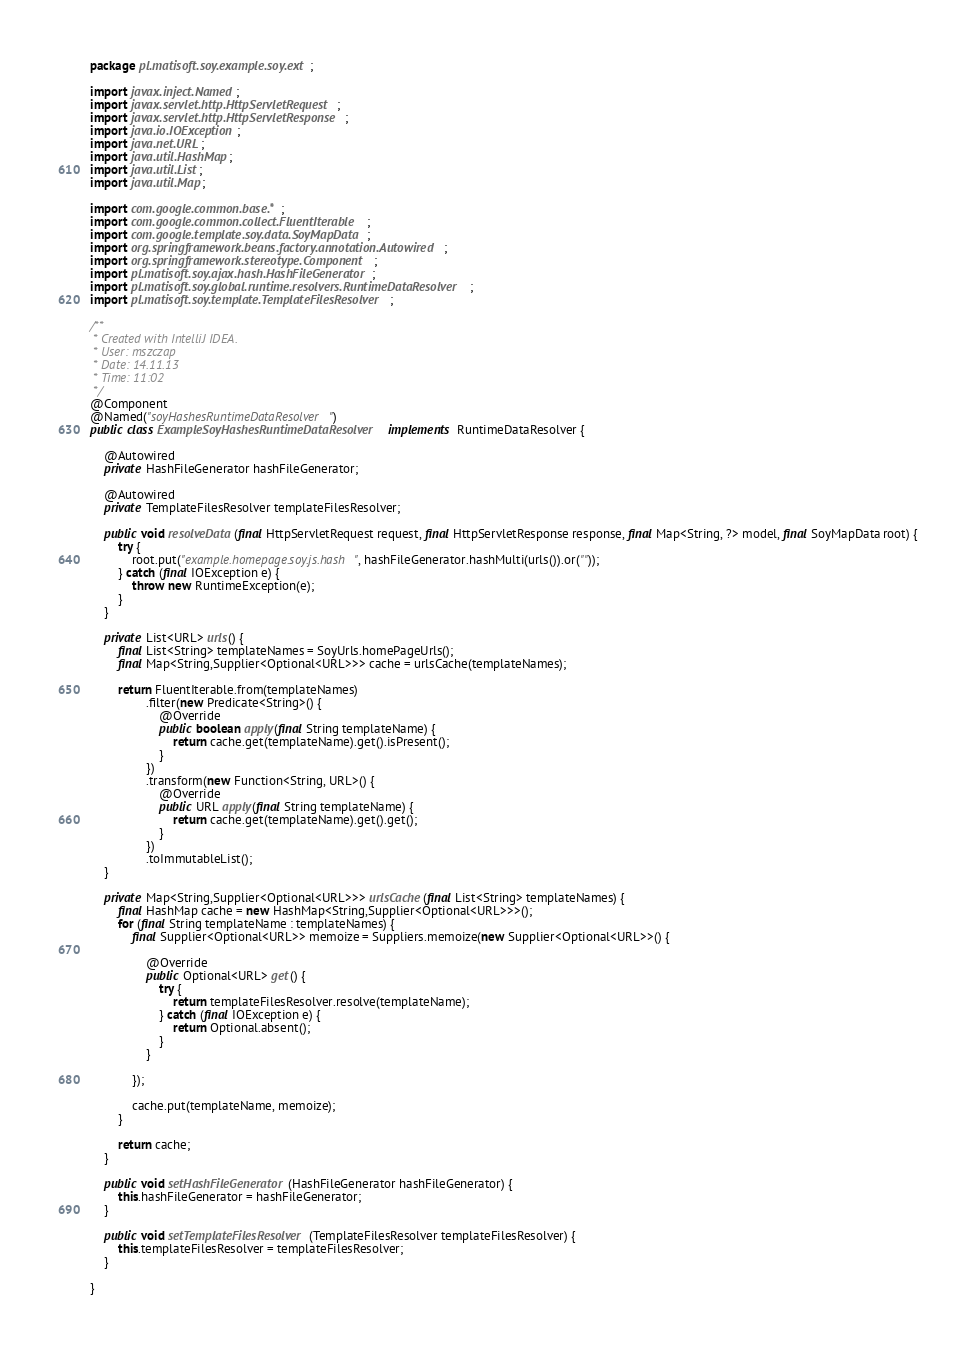<code> <loc_0><loc_0><loc_500><loc_500><_Java_>package pl.matisoft.soy.example.soy.ext;

import javax.inject.Named;
import javax.servlet.http.HttpServletRequest;
import javax.servlet.http.HttpServletResponse;
import java.io.IOException;
import java.net.URL;
import java.util.HashMap;
import java.util.List;
import java.util.Map;

import com.google.common.base.*;
import com.google.common.collect.FluentIterable;
import com.google.template.soy.data.SoyMapData;
import org.springframework.beans.factory.annotation.Autowired;
import org.springframework.stereotype.Component;
import pl.matisoft.soy.ajax.hash.HashFileGenerator;
import pl.matisoft.soy.global.runtime.resolvers.RuntimeDataResolver;
import pl.matisoft.soy.template.TemplateFilesResolver;

/**
 * Created with IntelliJ IDEA.
 * User: mszczap
 * Date: 14.11.13
 * Time: 11:02
 */
@Component
@Named("soyHashesRuntimeDataResolver")
public class ExampleSoyHashesRuntimeDataResolver implements RuntimeDataResolver {

    @Autowired
    private HashFileGenerator hashFileGenerator;

    @Autowired
    private TemplateFilesResolver templateFilesResolver;

    public void resolveData(final HttpServletRequest request, final HttpServletResponse response, final Map<String, ?> model, final SoyMapData root) {
        try {
            root.put("example.homepage.soy.js.hash", hashFileGenerator.hashMulti(urls()).or(""));
        } catch (final IOException e) {
            throw new RuntimeException(e);
        }
    }

    private List<URL> urls() {
        final List<String> templateNames = SoyUrls.homePageUrls();
        final Map<String,Supplier<Optional<URL>>> cache = urlsCache(templateNames);

        return FluentIterable.from(templateNames)
                .filter(new Predicate<String>() {
                    @Override
                    public boolean apply(final String templateName) {
                        return cache.get(templateName).get().isPresent();
                    }
                })
                .transform(new Function<String, URL>() {
                    @Override
                    public URL apply(final String templateName) {
                        return cache.get(templateName).get().get();
                    }
                })
                .toImmutableList();
    }

    private Map<String,Supplier<Optional<URL>>> urlsCache(final List<String> templateNames) {
        final HashMap cache = new HashMap<String,Supplier<Optional<URL>>>();
        for (final String templateName : templateNames) {
            final Supplier<Optional<URL>> memoize = Suppliers.memoize(new Supplier<Optional<URL>>() {

                @Override
                public Optional<URL> get() {
                    try {
                        return templateFilesResolver.resolve(templateName);
                    } catch (final IOException e) {
                        return Optional.absent();
                    }
                }

            });

            cache.put(templateName, memoize);
        }

        return cache;
    }

    public void setHashFileGenerator(HashFileGenerator hashFileGenerator) {
        this.hashFileGenerator = hashFileGenerator;
    }

    public void setTemplateFilesResolver(TemplateFilesResolver templateFilesResolver) {
        this.templateFilesResolver = templateFilesResolver;
    }

}
</code> 